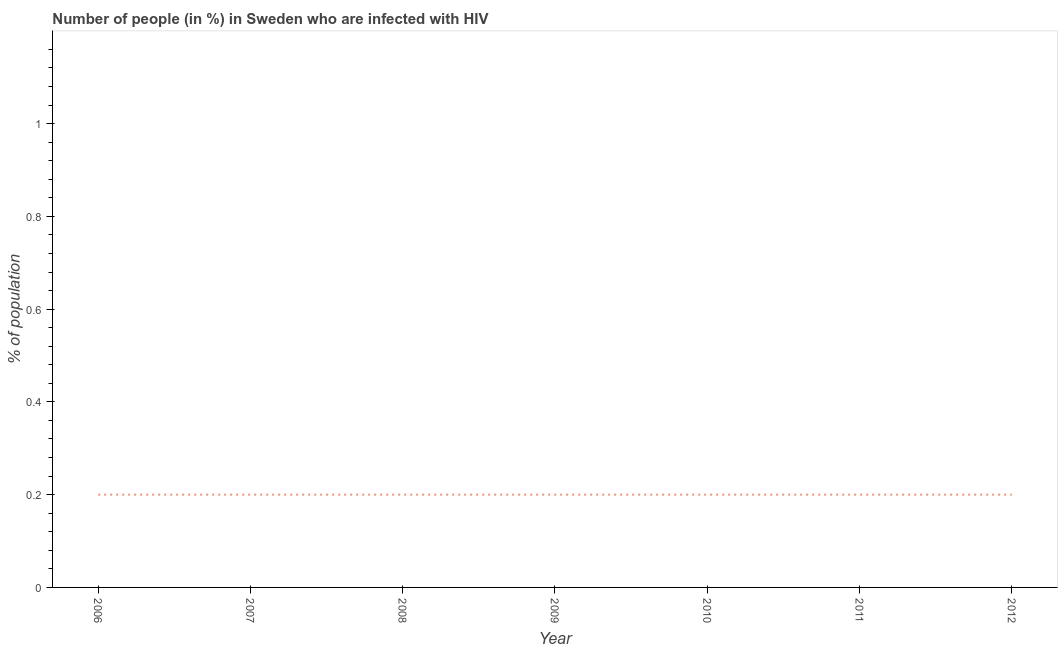What is the number of people infected with hiv in 2012?
Your answer should be compact. 0.2. In which year was the number of people infected with hiv maximum?
Provide a short and direct response. 2006. What is the sum of the number of people infected with hiv?
Give a very brief answer. 1.4. What is the difference between the number of people infected with hiv in 2007 and 2011?
Keep it short and to the point. 0. What is the average number of people infected with hiv per year?
Offer a terse response. 0.2. What is the median number of people infected with hiv?
Provide a short and direct response. 0.2. Is the number of people infected with hiv in 2007 less than that in 2011?
Make the answer very short. No. What is the difference between the highest and the second highest number of people infected with hiv?
Offer a very short reply. 0. Is the sum of the number of people infected with hiv in 2008 and 2011 greater than the maximum number of people infected with hiv across all years?
Your response must be concise. Yes. In how many years, is the number of people infected with hiv greater than the average number of people infected with hiv taken over all years?
Give a very brief answer. 7. Does the number of people infected with hiv monotonically increase over the years?
Your answer should be compact. No. How many years are there in the graph?
Your response must be concise. 7. Does the graph contain any zero values?
Your answer should be compact. No. Does the graph contain grids?
Ensure brevity in your answer.  No. What is the title of the graph?
Your response must be concise. Number of people (in %) in Sweden who are infected with HIV. What is the label or title of the Y-axis?
Your answer should be compact. % of population. What is the % of population in 2007?
Make the answer very short. 0.2. What is the % of population of 2009?
Keep it short and to the point. 0.2. What is the % of population in 2011?
Offer a very short reply. 0.2. What is the % of population in 2012?
Provide a short and direct response. 0.2. What is the difference between the % of population in 2006 and 2010?
Offer a very short reply. 0. What is the difference between the % of population in 2007 and 2011?
Make the answer very short. 0. What is the difference between the % of population in 2007 and 2012?
Ensure brevity in your answer.  0. What is the difference between the % of population in 2008 and 2009?
Ensure brevity in your answer.  0. What is the difference between the % of population in 2008 and 2010?
Ensure brevity in your answer.  0. What is the difference between the % of population in 2008 and 2012?
Your answer should be compact. 0. What is the difference between the % of population in 2009 and 2010?
Make the answer very short. 0. What is the ratio of the % of population in 2006 to that in 2007?
Ensure brevity in your answer.  1. What is the ratio of the % of population in 2006 to that in 2008?
Provide a succinct answer. 1. What is the ratio of the % of population in 2006 to that in 2010?
Your answer should be compact. 1. What is the ratio of the % of population in 2006 to that in 2011?
Give a very brief answer. 1. What is the ratio of the % of population in 2006 to that in 2012?
Make the answer very short. 1. What is the ratio of the % of population in 2007 to that in 2008?
Give a very brief answer. 1. What is the ratio of the % of population in 2007 to that in 2010?
Your answer should be compact. 1. What is the ratio of the % of population in 2008 to that in 2009?
Your answer should be very brief. 1. What is the ratio of the % of population in 2008 to that in 2010?
Give a very brief answer. 1. What is the ratio of the % of population in 2008 to that in 2011?
Make the answer very short. 1. What is the ratio of the % of population in 2010 to that in 2011?
Give a very brief answer. 1. 